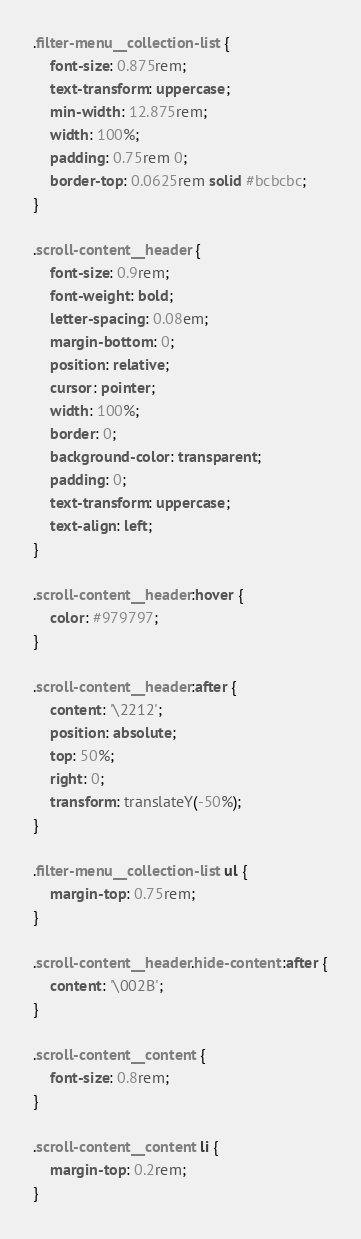<code> <loc_0><loc_0><loc_500><loc_500><_CSS_>.filter-menu__collection-list {
    font-size: 0.875rem;
    text-transform: uppercase;
    min-width: 12.875rem;
    width: 100%;
    padding: 0.75rem 0;
    border-top: 0.0625rem solid #bcbcbc;
}

.scroll-content__header {
    font-size: 0.9rem;
    font-weight: bold;
    letter-spacing: 0.08em;
    margin-bottom: 0;
    position: relative;
    cursor: pointer;
    width: 100%;
    border: 0;
    background-color: transparent;
    padding: 0;
    text-transform: uppercase;
    text-align: left;
}

.scroll-content__header:hover {
    color: #979797;
}

.scroll-content__header:after {
    content: '\2212';
    position: absolute;
    top: 50%;
    right: 0;
    transform: translateY(-50%);
}

.filter-menu__collection-list ul {
    margin-top: 0.75rem;
}

.scroll-content__header.hide-content:after {
    content: '\002B';
}

.scroll-content__content {
    font-size: 0.8rem;
}

.scroll-content__content li {
    margin-top: 0.2rem;
}
</code> 